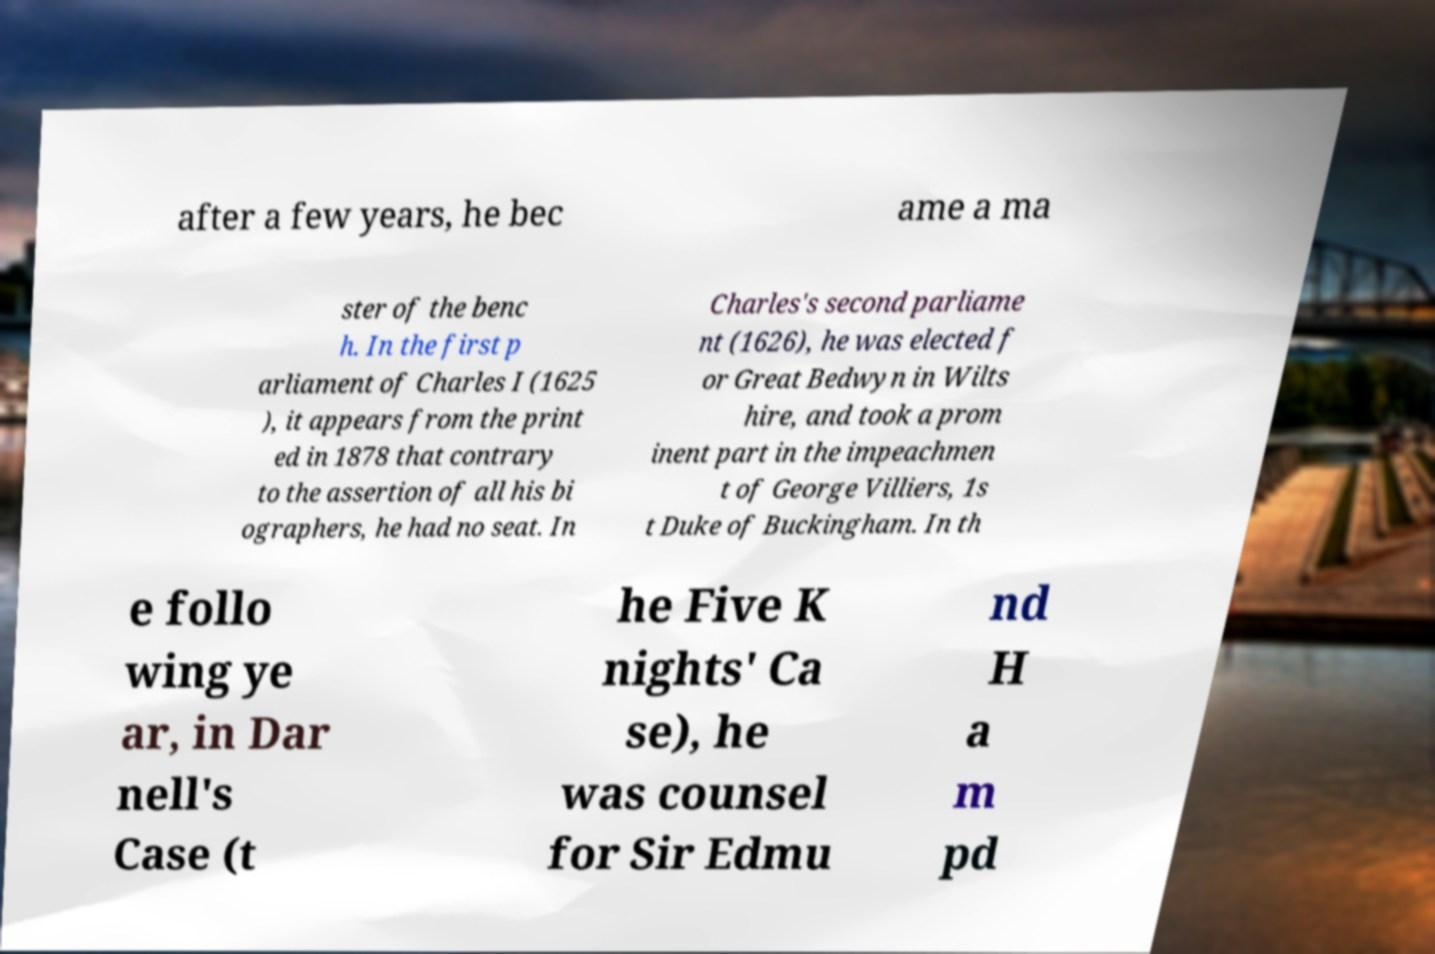What messages or text are displayed in this image? I need them in a readable, typed format. after a few years, he bec ame a ma ster of the benc h. In the first p arliament of Charles I (1625 ), it appears from the print ed in 1878 that contrary to the assertion of all his bi ographers, he had no seat. In Charles's second parliame nt (1626), he was elected f or Great Bedwyn in Wilts hire, and took a prom inent part in the impeachmen t of George Villiers, 1s t Duke of Buckingham. In th e follo wing ye ar, in Dar nell's Case (t he Five K nights' Ca se), he was counsel for Sir Edmu nd H a m pd 